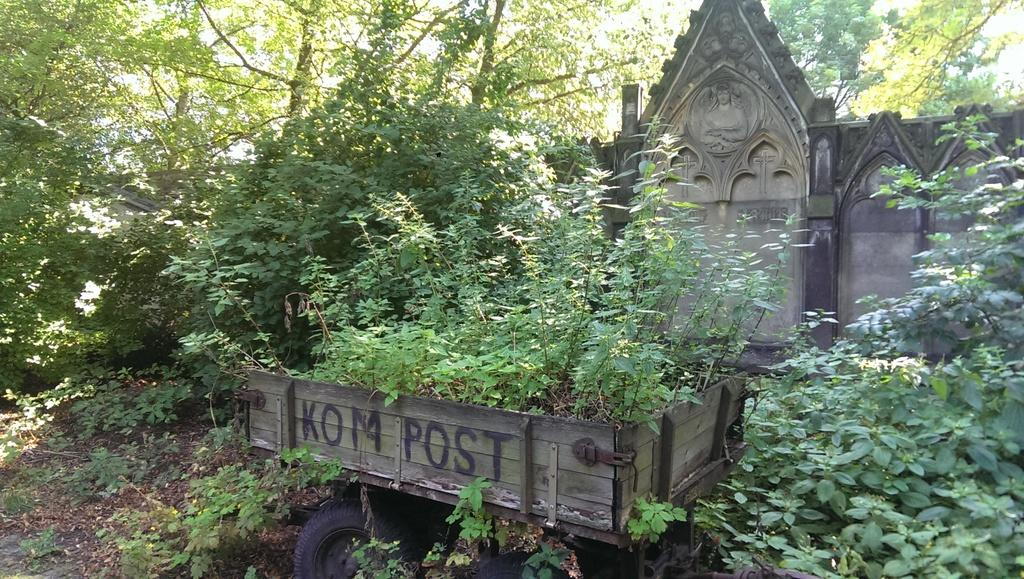What types of vegetation are present in the image? The image contains plants and trees. What is the weather like in the image? It is a sunny day in the image. What object can be used for carrying items in the image? There is a cart in the image. What type of structure is visible in the image? There is a wall in the image. What can be found on the left side of the image? There are dry leaves on the left side of the image. What type of ink can be seen dripping from the tree in the image? There is no ink present in the image; it is a natural scene with plants, trees, and dry leaves. 